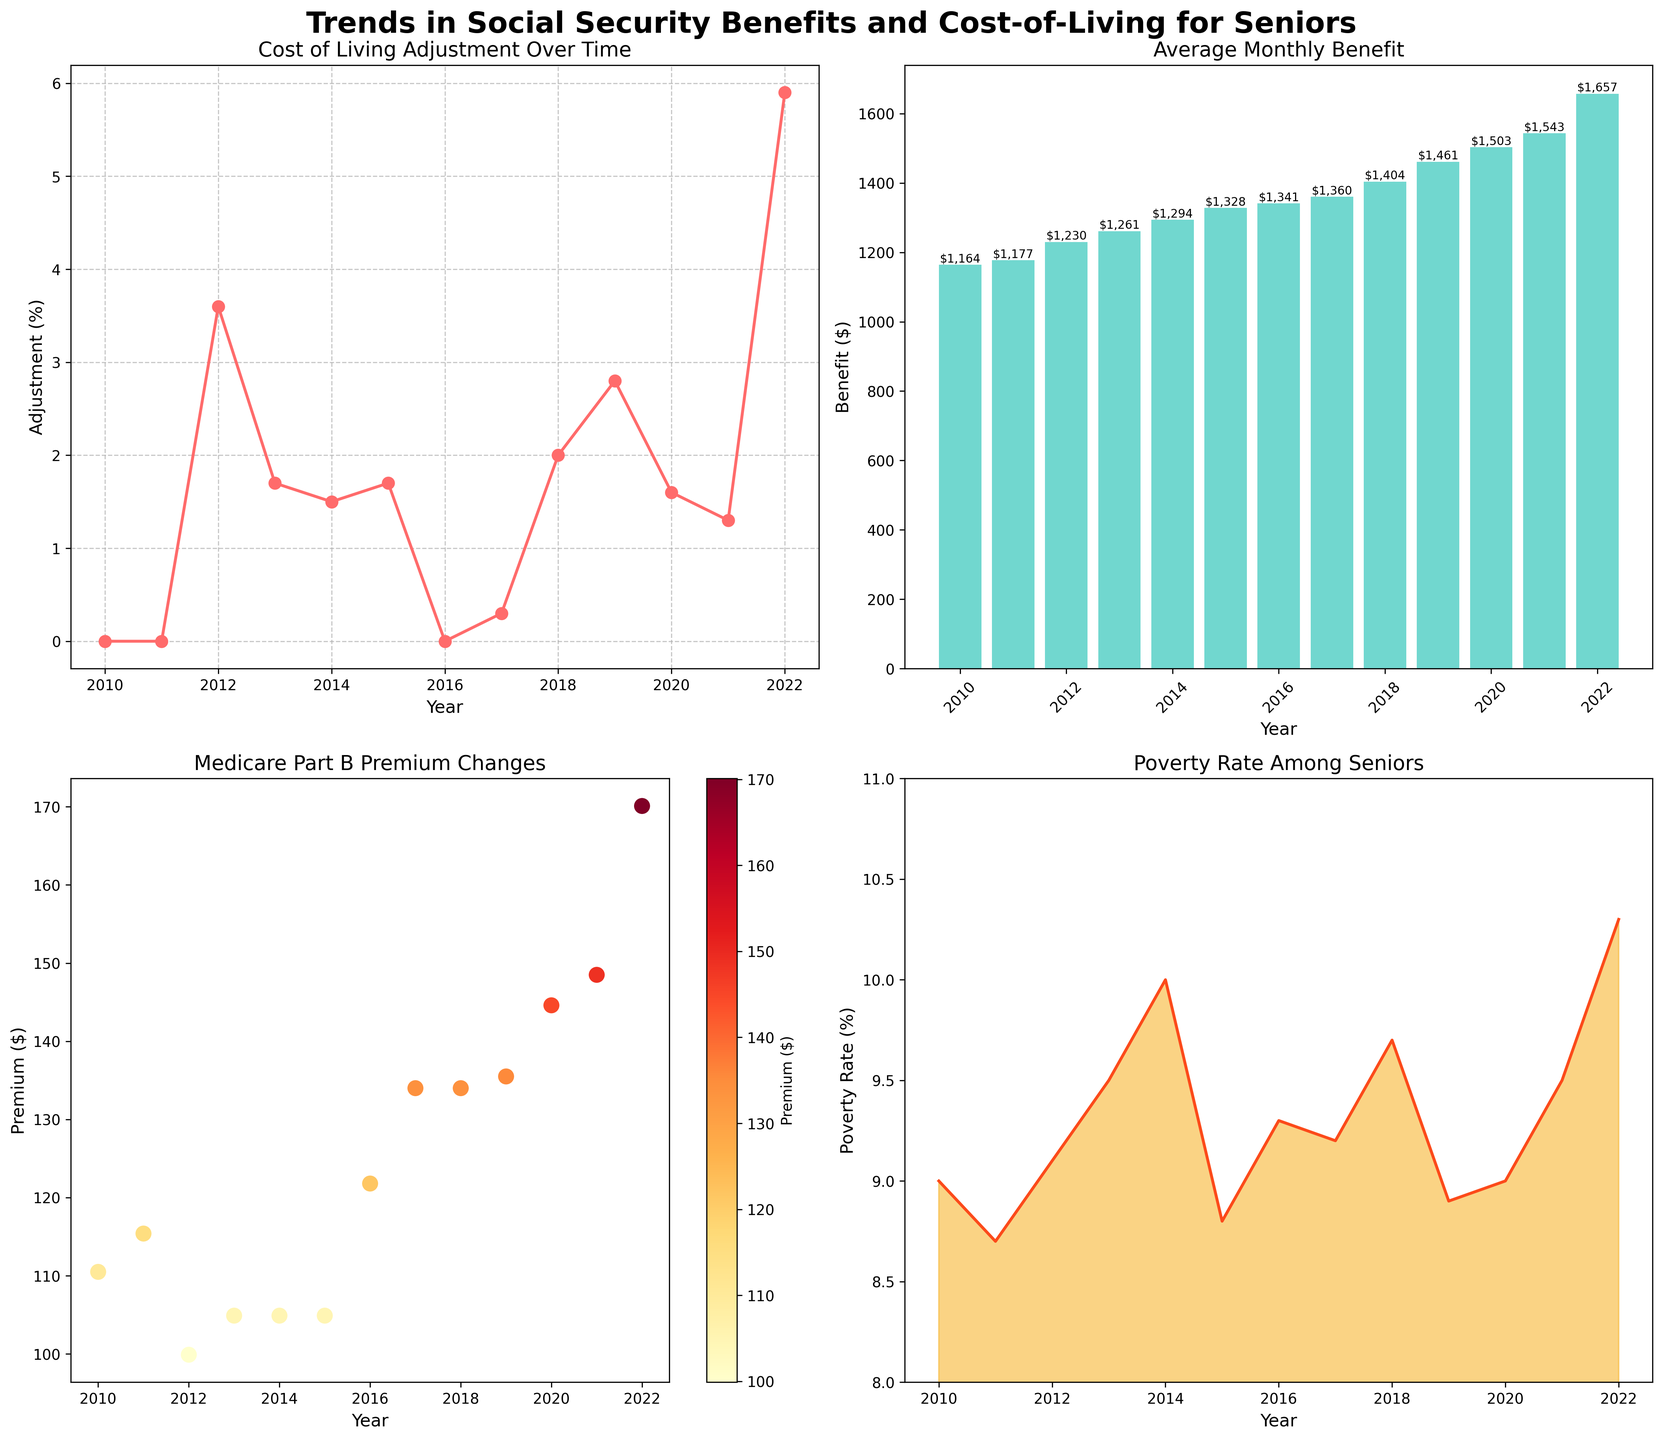Which year had the highest Cost of Living Adjustment (%)? The highest Cost of Living Adjustment is 5.9% in the line plot. This occurs at the year 2022.
Answer: 2022 What is the average monthly benefit for the year 2018? In the bar plot, the average monthly benefit for the year 2018 is labeled on the top of the bar at $1,404.
Answer: $1,404 How has the Medicare Part B Premium changed from 2013 to 2020? In the scatter plot, the Medicare Part B Premium increased from $104.90 in 2013 to $144.60 in 2020.
Answer: Increased Compare the poverty rate for seniors between 2014 and 2022. Which year had a higher rate? In the area plot, the poverty rate for seniors in 2014 is 10.0%, and in 2022 it is 10.3%. Therefore, 2022 had a higher rate.
Answer: 2022 Explain the trend in the Cost of Living Adjustment (%) over time. In the line plot, the Cost of Living Adjustment showed infrequent but significant adjustments, with a noticeable spike in 2022 at 5.9%.
Answer: Varied, with a spike in 2022 Which year experienced the largest increase in the average monthly benefit compared to the previous year? By examining the bar plot, the largest increase appears between 2021 ($1,543) and 2022 ($1,657). The difference is $1,657 - $1,543 = $114.
Answer: 2022 Was there any year where the Cost of Living Adjustment was 0%? If so, which years? Yes, the line plot shows 0% Cost of Living Adjustment in 2010, 2011, and 2016.
Answer: 2010, 2011, 2016 How does the trend in Medicare Part B Premiums compare to the trend in Poverty Rate for Seniors? The scatter plot shows a consistent increase in Medicare Part B Premiums, while the area plot for Poverty Rate for Seniors varies, peaking around 2014, decreasing, and then rising again in 2022.
Answer: Medicare premiums increased; Poverty rate varied What are the labels on the x-axis and y-axis of the top right subplot? The bar plot (top right subplot) has "Year" on the x-axis and "Benefit ($)" on the y-axis.
Answer: Year; Benefit ($) Identify the subplot that suggests a significant spike in the most recent year. The line plot in the top left shows a significant spike in the Cost of Living Adjustment in 2022.
Answer: Line plot (top left) 